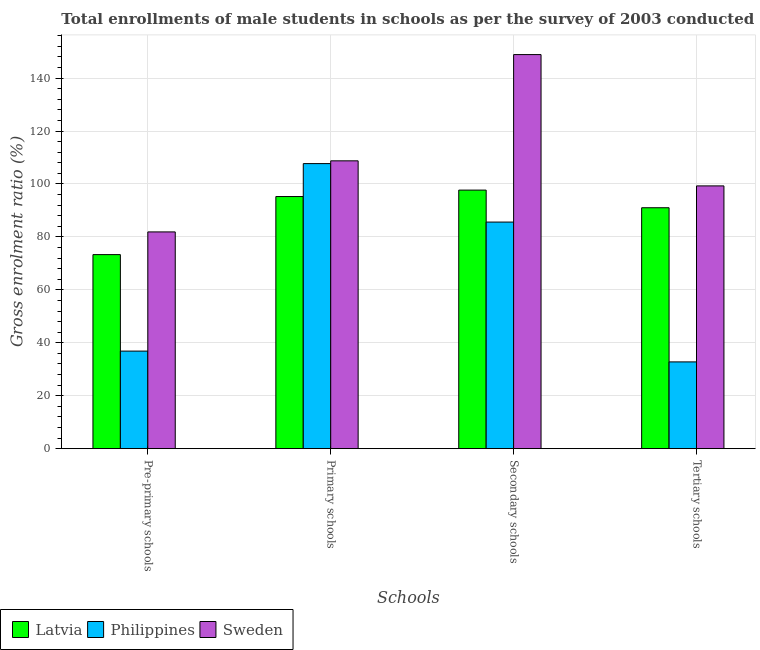How many different coloured bars are there?
Give a very brief answer. 3. How many groups of bars are there?
Offer a very short reply. 4. Are the number of bars per tick equal to the number of legend labels?
Make the answer very short. Yes. Are the number of bars on each tick of the X-axis equal?
Your answer should be compact. Yes. How many bars are there on the 1st tick from the left?
Your answer should be very brief. 3. What is the label of the 2nd group of bars from the left?
Keep it short and to the point. Primary schools. What is the gross enrolment ratio(male) in pre-primary schools in Philippines?
Keep it short and to the point. 36.86. Across all countries, what is the maximum gross enrolment ratio(male) in tertiary schools?
Provide a succinct answer. 99.27. Across all countries, what is the minimum gross enrolment ratio(male) in secondary schools?
Offer a terse response. 85.6. In which country was the gross enrolment ratio(male) in pre-primary schools maximum?
Keep it short and to the point. Sweden. What is the total gross enrolment ratio(male) in tertiary schools in the graph?
Provide a short and direct response. 223.06. What is the difference between the gross enrolment ratio(male) in secondary schools in Latvia and that in Sweden?
Offer a very short reply. -51.2. What is the difference between the gross enrolment ratio(male) in tertiary schools in Latvia and the gross enrolment ratio(male) in primary schools in Sweden?
Make the answer very short. -17.72. What is the average gross enrolment ratio(male) in pre-primary schools per country?
Keep it short and to the point. 64.02. What is the difference between the gross enrolment ratio(male) in tertiary schools and gross enrolment ratio(male) in primary schools in Philippines?
Offer a very short reply. -74.91. In how many countries, is the gross enrolment ratio(male) in primary schools greater than 48 %?
Ensure brevity in your answer.  3. What is the ratio of the gross enrolment ratio(male) in tertiary schools in Philippines to that in Latvia?
Your response must be concise. 0.36. Is the difference between the gross enrolment ratio(male) in primary schools in Latvia and Sweden greater than the difference between the gross enrolment ratio(male) in pre-primary schools in Latvia and Sweden?
Offer a very short reply. No. What is the difference between the highest and the second highest gross enrolment ratio(male) in primary schools?
Your answer should be very brief. 1.04. What is the difference between the highest and the lowest gross enrolment ratio(male) in tertiary schools?
Keep it short and to the point. 66.49. Is the sum of the gross enrolment ratio(male) in tertiary schools in Philippines and Latvia greater than the maximum gross enrolment ratio(male) in pre-primary schools across all countries?
Provide a succinct answer. Yes. What does the 1st bar from the left in Secondary schools represents?
Your answer should be compact. Latvia. What does the 1st bar from the right in Primary schools represents?
Keep it short and to the point. Sweden. Is it the case that in every country, the sum of the gross enrolment ratio(male) in pre-primary schools and gross enrolment ratio(male) in primary schools is greater than the gross enrolment ratio(male) in secondary schools?
Your response must be concise. Yes. How many bars are there?
Keep it short and to the point. 12. What is the difference between two consecutive major ticks on the Y-axis?
Provide a succinct answer. 20. Are the values on the major ticks of Y-axis written in scientific E-notation?
Your response must be concise. No. How are the legend labels stacked?
Your answer should be very brief. Horizontal. What is the title of the graph?
Keep it short and to the point. Total enrollments of male students in schools as per the survey of 2003 conducted in different countries. Does "Italy" appear as one of the legend labels in the graph?
Ensure brevity in your answer.  No. What is the label or title of the X-axis?
Offer a very short reply. Schools. What is the Gross enrolment ratio (%) in Latvia in Pre-primary schools?
Provide a short and direct response. 73.31. What is the Gross enrolment ratio (%) in Philippines in Pre-primary schools?
Your response must be concise. 36.86. What is the Gross enrolment ratio (%) of Sweden in Pre-primary schools?
Provide a succinct answer. 81.89. What is the Gross enrolment ratio (%) of Latvia in Primary schools?
Your response must be concise. 95.25. What is the Gross enrolment ratio (%) of Philippines in Primary schools?
Your answer should be compact. 107.69. What is the Gross enrolment ratio (%) in Sweden in Primary schools?
Your response must be concise. 108.73. What is the Gross enrolment ratio (%) in Latvia in Secondary schools?
Give a very brief answer. 97.68. What is the Gross enrolment ratio (%) in Philippines in Secondary schools?
Provide a short and direct response. 85.6. What is the Gross enrolment ratio (%) in Sweden in Secondary schools?
Give a very brief answer. 148.88. What is the Gross enrolment ratio (%) in Latvia in Tertiary schools?
Ensure brevity in your answer.  91.02. What is the Gross enrolment ratio (%) of Philippines in Tertiary schools?
Offer a terse response. 32.78. What is the Gross enrolment ratio (%) of Sweden in Tertiary schools?
Your answer should be very brief. 99.27. Across all Schools, what is the maximum Gross enrolment ratio (%) of Latvia?
Your response must be concise. 97.68. Across all Schools, what is the maximum Gross enrolment ratio (%) in Philippines?
Your answer should be compact. 107.69. Across all Schools, what is the maximum Gross enrolment ratio (%) of Sweden?
Your answer should be very brief. 148.88. Across all Schools, what is the minimum Gross enrolment ratio (%) of Latvia?
Your answer should be compact. 73.31. Across all Schools, what is the minimum Gross enrolment ratio (%) in Philippines?
Ensure brevity in your answer.  32.78. Across all Schools, what is the minimum Gross enrolment ratio (%) in Sweden?
Make the answer very short. 81.89. What is the total Gross enrolment ratio (%) of Latvia in the graph?
Ensure brevity in your answer.  357.25. What is the total Gross enrolment ratio (%) in Philippines in the graph?
Provide a succinct answer. 262.94. What is the total Gross enrolment ratio (%) in Sweden in the graph?
Your response must be concise. 438.77. What is the difference between the Gross enrolment ratio (%) in Latvia in Pre-primary schools and that in Primary schools?
Offer a very short reply. -21.94. What is the difference between the Gross enrolment ratio (%) of Philippines in Pre-primary schools and that in Primary schools?
Give a very brief answer. -70.83. What is the difference between the Gross enrolment ratio (%) in Sweden in Pre-primary schools and that in Primary schools?
Provide a succinct answer. -26.85. What is the difference between the Gross enrolment ratio (%) of Latvia in Pre-primary schools and that in Secondary schools?
Provide a succinct answer. -24.37. What is the difference between the Gross enrolment ratio (%) in Philippines in Pre-primary schools and that in Secondary schools?
Offer a very short reply. -48.74. What is the difference between the Gross enrolment ratio (%) of Sweden in Pre-primary schools and that in Secondary schools?
Ensure brevity in your answer.  -66.99. What is the difference between the Gross enrolment ratio (%) of Latvia in Pre-primary schools and that in Tertiary schools?
Your answer should be compact. -17.71. What is the difference between the Gross enrolment ratio (%) in Philippines in Pre-primary schools and that in Tertiary schools?
Make the answer very short. 4.08. What is the difference between the Gross enrolment ratio (%) in Sweden in Pre-primary schools and that in Tertiary schools?
Give a very brief answer. -17.38. What is the difference between the Gross enrolment ratio (%) in Latvia in Primary schools and that in Secondary schools?
Offer a very short reply. -2.43. What is the difference between the Gross enrolment ratio (%) in Philippines in Primary schools and that in Secondary schools?
Ensure brevity in your answer.  22.09. What is the difference between the Gross enrolment ratio (%) of Sweden in Primary schools and that in Secondary schools?
Provide a succinct answer. -40.14. What is the difference between the Gross enrolment ratio (%) of Latvia in Primary schools and that in Tertiary schools?
Offer a terse response. 4.23. What is the difference between the Gross enrolment ratio (%) in Philippines in Primary schools and that in Tertiary schools?
Provide a short and direct response. 74.91. What is the difference between the Gross enrolment ratio (%) of Sweden in Primary schools and that in Tertiary schools?
Keep it short and to the point. 9.47. What is the difference between the Gross enrolment ratio (%) of Latvia in Secondary schools and that in Tertiary schools?
Your response must be concise. 6.66. What is the difference between the Gross enrolment ratio (%) of Philippines in Secondary schools and that in Tertiary schools?
Your answer should be very brief. 52.82. What is the difference between the Gross enrolment ratio (%) of Sweden in Secondary schools and that in Tertiary schools?
Give a very brief answer. 49.61. What is the difference between the Gross enrolment ratio (%) of Latvia in Pre-primary schools and the Gross enrolment ratio (%) of Philippines in Primary schools?
Give a very brief answer. -34.39. What is the difference between the Gross enrolment ratio (%) of Latvia in Pre-primary schools and the Gross enrolment ratio (%) of Sweden in Primary schools?
Offer a very short reply. -35.43. What is the difference between the Gross enrolment ratio (%) in Philippines in Pre-primary schools and the Gross enrolment ratio (%) in Sweden in Primary schools?
Offer a very short reply. -71.87. What is the difference between the Gross enrolment ratio (%) in Latvia in Pre-primary schools and the Gross enrolment ratio (%) in Philippines in Secondary schools?
Provide a succinct answer. -12.29. What is the difference between the Gross enrolment ratio (%) in Latvia in Pre-primary schools and the Gross enrolment ratio (%) in Sweden in Secondary schools?
Your answer should be very brief. -75.57. What is the difference between the Gross enrolment ratio (%) of Philippines in Pre-primary schools and the Gross enrolment ratio (%) of Sweden in Secondary schools?
Your answer should be very brief. -112.02. What is the difference between the Gross enrolment ratio (%) of Latvia in Pre-primary schools and the Gross enrolment ratio (%) of Philippines in Tertiary schools?
Offer a terse response. 40.53. What is the difference between the Gross enrolment ratio (%) in Latvia in Pre-primary schools and the Gross enrolment ratio (%) in Sweden in Tertiary schools?
Offer a terse response. -25.96. What is the difference between the Gross enrolment ratio (%) of Philippines in Pre-primary schools and the Gross enrolment ratio (%) of Sweden in Tertiary schools?
Offer a very short reply. -62.41. What is the difference between the Gross enrolment ratio (%) in Latvia in Primary schools and the Gross enrolment ratio (%) in Philippines in Secondary schools?
Offer a very short reply. 9.65. What is the difference between the Gross enrolment ratio (%) of Latvia in Primary schools and the Gross enrolment ratio (%) of Sweden in Secondary schools?
Provide a succinct answer. -53.63. What is the difference between the Gross enrolment ratio (%) in Philippines in Primary schools and the Gross enrolment ratio (%) in Sweden in Secondary schools?
Offer a very short reply. -41.18. What is the difference between the Gross enrolment ratio (%) of Latvia in Primary schools and the Gross enrolment ratio (%) of Philippines in Tertiary schools?
Offer a very short reply. 62.47. What is the difference between the Gross enrolment ratio (%) in Latvia in Primary schools and the Gross enrolment ratio (%) in Sweden in Tertiary schools?
Your response must be concise. -4.02. What is the difference between the Gross enrolment ratio (%) in Philippines in Primary schools and the Gross enrolment ratio (%) in Sweden in Tertiary schools?
Make the answer very short. 8.43. What is the difference between the Gross enrolment ratio (%) of Latvia in Secondary schools and the Gross enrolment ratio (%) of Philippines in Tertiary schools?
Your response must be concise. 64.9. What is the difference between the Gross enrolment ratio (%) of Latvia in Secondary schools and the Gross enrolment ratio (%) of Sweden in Tertiary schools?
Provide a succinct answer. -1.59. What is the difference between the Gross enrolment ratio (%) of Philippines in Secondary schools and the Gross enrolment ratio (%) of Sweden in Tertiary schools?
Give a very brief answer. -13.66. What is the average Gross enrolment ratio (%) in Latvia per Schools?
Offer a terse response. 89.31. What is the average Gross enrolment ratio (%) in Philippines per Schools?
Make the answer very short. 65.73. What is the average Gross enrolment ratio (%) of Sweden per Schools?
Offer a terse response. 109.69. What is the difference between the Gross enrolment ratio (%) of Latvia and Gross enrolment ratio (%) of Philippines in Pre-primary schools?
Offer a very short reply. 36.45. What is the difference between the Gross enrolment ratio (%) of Latvia and Gross enrolment ratio (%) of Sweden in Pre-primary schools?
Provide a succinct answer. -8.58. What is the difference between the Gross enrolment ratio (%) in Philippines and Gross enrolment ratio (%) in Sweden in Pre-primary schools?
Offer a terse response. -45.03. What is the difference between the Gross enrolment ratio (%) of Latvia and Gross enrolment ratio (%) of Philippines in Primary schools?
Your response must be concise. -12.44. What is the difference between the Gross enrolment ratio (%) in Latvia and Gross enrolment ratio (%) in Sweden in Primary schools?
Provide a short and direct response. -13.48. What is the difference between the Gross enrolment ratio (%) of Philippines and Gross enrolment ratio (%) of Sweden in Primary schools?
Make the answer very short. -1.04. What is the difference between the Gross enrolment ratio (%) of Latvia and Gross enrolment ratio (%) of Philippines in Secondary schools?
Provide a succinct answer. 12.08. What is the difference between the Gross enrolment ratio (%) in Latvia and Gross enrolment ratio (%) in Sweden in Secondary schools?
Your response must be concise. -51.2. What is the difference between the Gross enrolment ratio (%) of Philippines and Gross enrolment ratio (%) of Sweden in Secondary schools?
Make the answer very short. -63.27. What is the difference between the Gross enrolment ratio (%) of Latvia and Gross enrolment ratio (%) of Philippines in Tertiary schools?
Your answer should be compact. 58.23. What is the difference between the Gross enrolment ratio (%) of Latvia and Gross enrolment ratio (%) of Sweden in Tertiary schools?
Your answer should be compact. -8.25. What is the difference between the Gross enrolment ratio (%) in Philippines and Gross enrolment ratio (%) in Sweden in Tertiary schools?
Keep it short and to the point. -66.49. What is the ratio of the Gross enrolment ratio (%) of Latvia in Pre-primary schools to that in Primary schools?
Your response must be concise. 0.77. What is the ratio of the Gross enrolment ratio (%) in Philippines in Pre-primary schools to that in Primary schools?
Make the answer very short. 0.34. What is the ratio of the Gross enrolment ratio (%) of Sweden in Pre-primary schools to that in Primary schools?
Offer a terse response. 0.75. What is the ratio of the Gross enrolment ratio (%) of Latvia in Pre-primary schools to that in Secondary schools?
Provide a short and direct response. 0.75. What is the ratio of the Gross enrolment ratio (%) of Philippines in Pre-primary schools to that in Secondary schools?
Your answer should be very brief. 0.43. What is the ratio of the Gross enrolment ratio (%) of Sweden in Pre-primary schools to that in Secondary schools?
Provide a succinct answer. 0.55. What is the ratio of the Gross enrolment ratio (%) in Latvia in Pre-primary schools to that in Tertiary schools?
Offer a terse response. 0.81. What is the ratio of the Gross enrolment ratio (%) of Philippines in Pre-primary schools to that in Tertiary schools?
Offer a terse response. 1.12. What is the ratio of the Gross enrolment ratio (%) of Sweden in Pre-primary schools to that in Tertiary schools?
Provide a short and direct response. 0.82. What is the ratio of the Gross enrolment ratio (%) of Latvia in Primary schools to that in Secondary schools?
Offer a very short reply. 0.98. What is the ratio of the Gross enrolment ratio (%) of Philippines in Primary schools to that in Secondary schools?
Keep it short and to the point. 1.26. What is the ratio of the Gross enrolment ratio (%) in Sweden in Primary schools to that in Secondary schools?
Your answer should be compact. 0.73. What is the ratio of the Gross enrolment ratio (%) in Latvia in Primary schools to that in Tertiary schools?
Keep it short and to the point. 1.05. What is the ratio of the Gross enrolment ratio (%) in Philippines in Primary schools to that in Tertiary schools?
Provide a succinct answer. 3.29. What is the ratio of the Gross enrolment ratio (%) in Sweden in Primary schools to that in Tertiary schools?
Provide a short and direct response. 1.1. What is the ratio of the Gross enrolment ratio (%) in Latvia in Secondary schools to that in Tertiary schools?
Ensure brevity in your answer.  1.07. What is the ratio of the Gross enrolment ratio (%) in Philippines in Secondary schools to that in Tertiary schools?
Ensure brevity in your answer.  2.61. What is the ratio of the Gross enrolment ratio (%) in Sweden in Secondary schools to that in Tertiary schools?
Give a very brief answer. 1.5. What is the difference between the highest and the second highest Gross enrolment ratio (%) of Latvia?
Your answer should be very brief. 2.43. What is the difference between the highest and the second highest Gross enrolment ratio (%) in Philippines?
Your answer should be very brief. 22.09. What is the difference between the highest and the second highest Gross enrolment ratio (%) in Sweden?
Your answer should be compact. 40.14. What is the difference between the highest and the lowest Gross enrolment ratio (%) of Latvia?
Provide a short and direct response. 24.37. What is the difference between the highest and the lowest Gross enrolment ratio (%) in Philippines?
Provide a succinct answer. 74.91. What is the difference between the highest and the lowest Gross enrolment ratio (%) in Sweden?
Give a very brief answer. 66.99. 